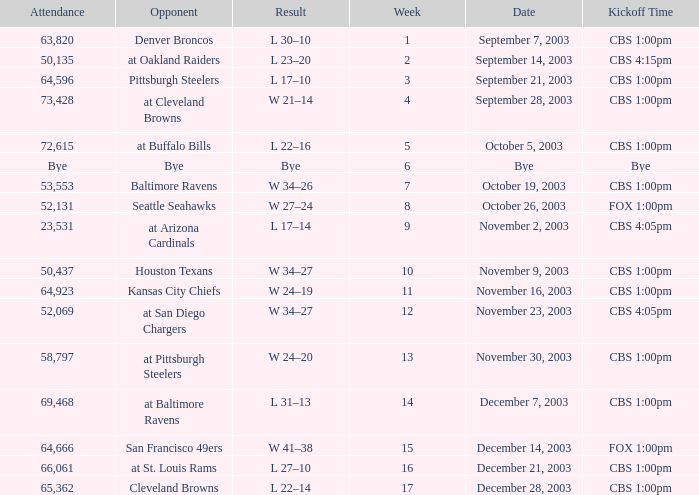What was the kickoff time on week 1? CBS 1:00pm. 